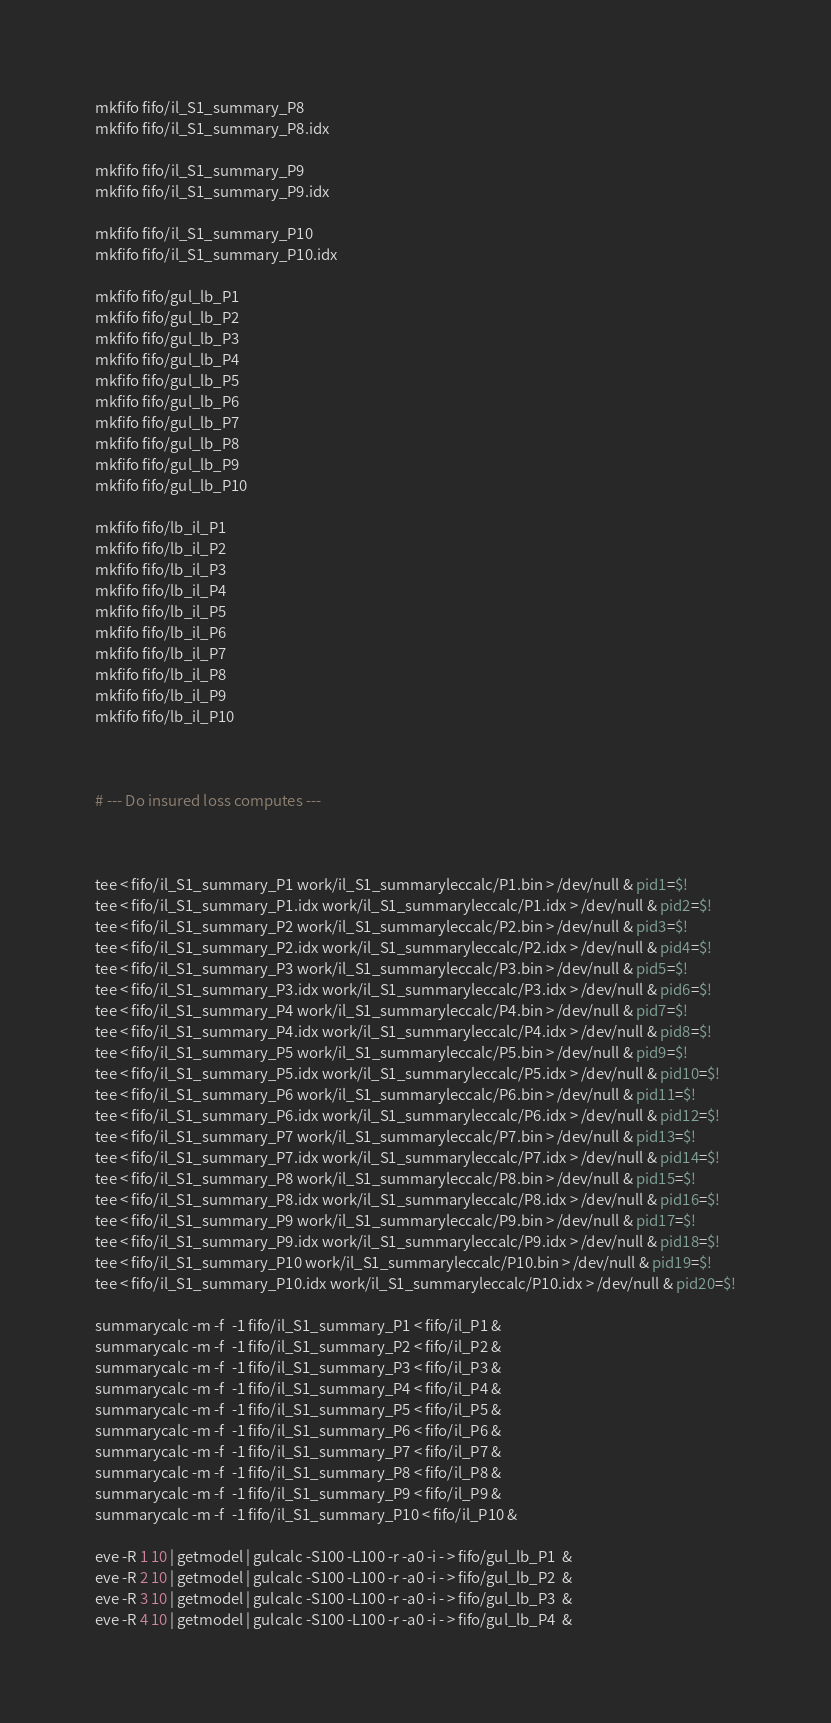<code> <loc_0><loc_0><loc_500><loc_500><_Bash_>mkfifo fifo/il_S1_summary_P8
mkfifo fifo/il_S1_summary_P8.idx

mkfifo fifo/il_S1_summary_P9
mkfifo fifo/il_S1_summary_P9.idx

mkfifo fifo/il_S1_summary_P10
mkfifo fifo/il_S1_summary_P10.idx

mkfifo fifo/gul_lb_P1
mkfifo fifo/gul_lb_P2
mkfifo fifo/gul_lb_P3
mkfifo fifo/gul_lb_P4
mkfifo fifo/gul_lb_P5
mkfifo fifo/gul_lb_P6
mkfifo fifo/gul_lb_P7
mkfifo fifo/gul_lb_P8
mkfifo fifo/gul_lb_P9
mkfifo fifo/gul_lb_P10

mkfifo fifo/lb_il_P1
mkfifo fifo/lb_il_P2
mkfifo fifo/lb_il_P3
mkfifo fifo/lb_il_P4
mkfifo fifo/lb_il_P5
mkfifo fifo/lb_il_P6
mkfifo fifo/lb_il_P7
mkfifo fifo/lb_il_P8
mkfifo fifo/lb_il_P9
mkfifo fifo/lb_il_P10



# --- Do insured loss computes ---



tee < fifo/il_S1_summary_P1 work/il_S1_summaryleccalc/P1.bin > /dev/null & pid1=$!
tee < fifo/il_S1_summary_P1.idx work/il_S1_summaryleccalc/P1.idx > /dev/null & pid2=$!
tee < fifo/il_S1_summary_P2 work/il_S1_summaryleccalc/P2.bin > /dev/null & pid3=$!
tee < fifo/il_S1_summary_P2.idx work/il_S1_summaryleccalc/P2.idx > /dev/null & pid4=$!
tee < fifo/il_S1_summary_P3 work/il_S1_summaryleccalc/P3.bin > /dev/null & pid5=$!
tee < fifo/il_S1_summary_P3.idx work/il_S1_summaryleccalc/P3.idx > /dev/null & pid6=$!
tee < fifo/il_S1_summary_P4 work/il_S1_summaryleccalc/P4.bin > /dev/null & pid7=$!
tee < fifo/il_S1_summary_P4.idx work/il_S1_summaryleccalc/P4.idx > /dev/null & pid8=$!
tee < fifo/il_S1_summary_P5 work/il_S1_summaryleccalc/P5.bin > /dev/null & pid9=$!
tee < fifo/il_S1_summary_P5.idx work/il_S1_summaryleccalc/P5.idx > /dev/null & pid10=$!
tee < fifo/il_S1_summary_P6 work/il_S1_summaryleccalc/P6.bin > /dev/null & pid11=$!
tee < fifo/il_S1_summary_P6.idx work/il_S1_summaryleccalc/P6.idx > /dev/null & pid12=$!
tee < fifo/il_S1_summary_P7 work/il_S1_summaryleccalc/P7.bin > /dev/null & pid13=$!
tee < fifo/il_S1_summary_P7.idx work/il_S1_summaryleccalc/P7.idx > /dev/null & pid14=$!
tee < fifo/il_S1_summary_P8 work/il_S1_summaryleccalc/P8.bin > /dev/null & pid15=$!
tee < fifo/il_S1_summary_P8.idx work/il_S1_summaryleccalc/P8.idx > /dev/null & pid16=$!
tee < fifo/il_S1_summary_P9 work/il_S1_summaryleccalc/P9.bin > /dev/null & pid17=$!
tee < fifo/il_S1_summary_P9.idx work/il_S1_summaryleccalc/P9.idx > /dev/null & pid18=$!
tee < fifo/il_S1_summary_P10 work/il_S1_summaryleccalc/P10.bin > /dev/null & pid19=$!
tee < fifo/il_S1_summary_P10.idx work/il_S1_summaryleccalc/P10.idx > /dev/null & pid20=$!

summarycalc -m -f  -1 fifo/il_S1_summary_P1 < fifo/il_P1 &
summarycalc -m -f  -1 fifo/il_S1_summary_P2 < fifo/il_P2 &
summarycalc -m -f  -1 fifo/il_S1_summary_P3 < fifo/il_P3 &
summarycalc -m -f  -1 fifo/il_S1_summary_P4 < fifo/il_P4 &
summarycalc -m -f  -1 fifo/il_S1_summary_P5 < fifo/il_P5 &
summarycalc -m -f  -1 fifo/il_S1_summary_P6 < fifo/il_P6 &
summarycalc -m -f  -1 fifo/il_S1_summary_P7 < fifo/il_P7 &
summarycalc -m -f  -1 fifo/il_S1_summary_P8 < fifo/il_P8 &
summarycalc -m -f  -1 fifo/il_S1_summary_P9 < fifo/il_P9 &
summarycalc -m -f  -1 fifo/il_S1_summary_P10 < fifo/il_P10 &

eve -R 1 10 | getmodel | gulcalc -S100 -L100 -r -a0 -i - > fifo/gul_lb_P1  &
eve -R 2 10 | getmodel | gulcalc -S100 -L100 -r -a0 -i - > fifo/gul_lb_P2  &
eve -R 3 10 | getmodel | gulcalc -S100 -L100 -r -a0 -i - > fifo/gul_lb_P3  &
eve -R 4 10 | getmodel | gulcalc -S100 -L100 -r -a0 -i - > fifo/gul_lb_P4  &</code> 